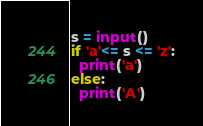Convert code to text. <code><loc_0><loc_0><loc_500><loc_500><_Python_>s = input()
if 'a'<= s <= 'z':
  print('a')
else:
  print('A')
</code> 